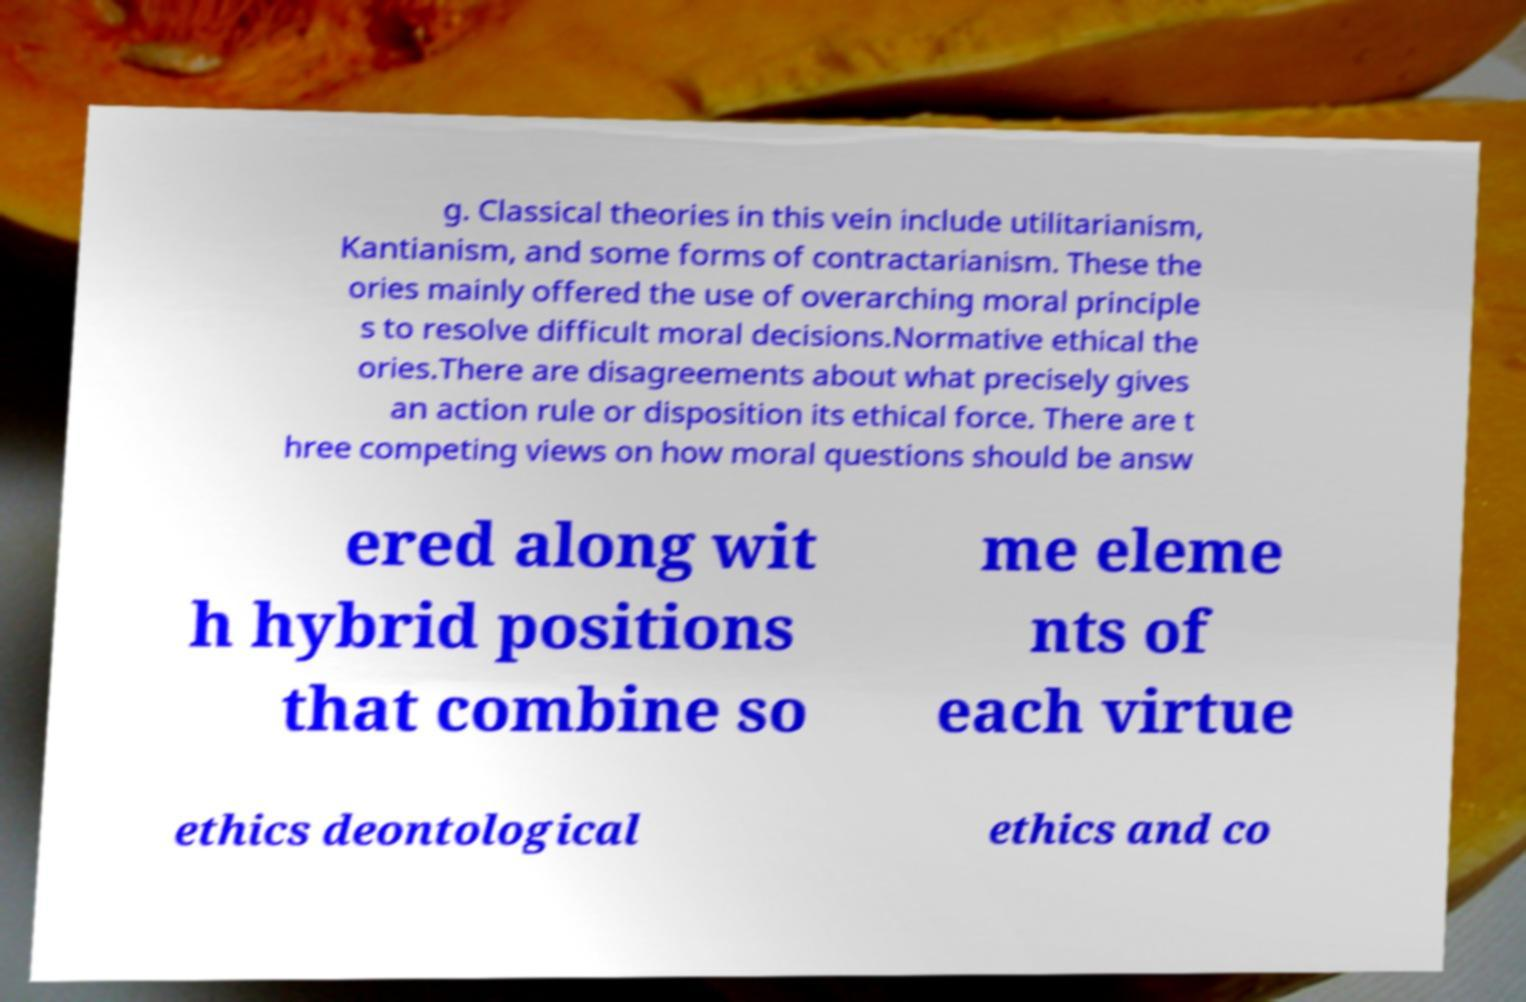For documentation purposes, I need the text within this image transcribed. Could you provide that? g. Classical theories in this vein include utilitarianism, Kantianism, and some forms of contractarianism. These the ories mainly offered the use of overarching moral principle s to resolve difficult moral decisions.Normative ethical the ories.There are disagreements about what precisely gives an action rule or disposition its ethical force. There are t hree competing views on how moral questions should be answ ered along wit h hybrid positions that combine so me eleme nts of each virtue ethics deontological ethics and co 